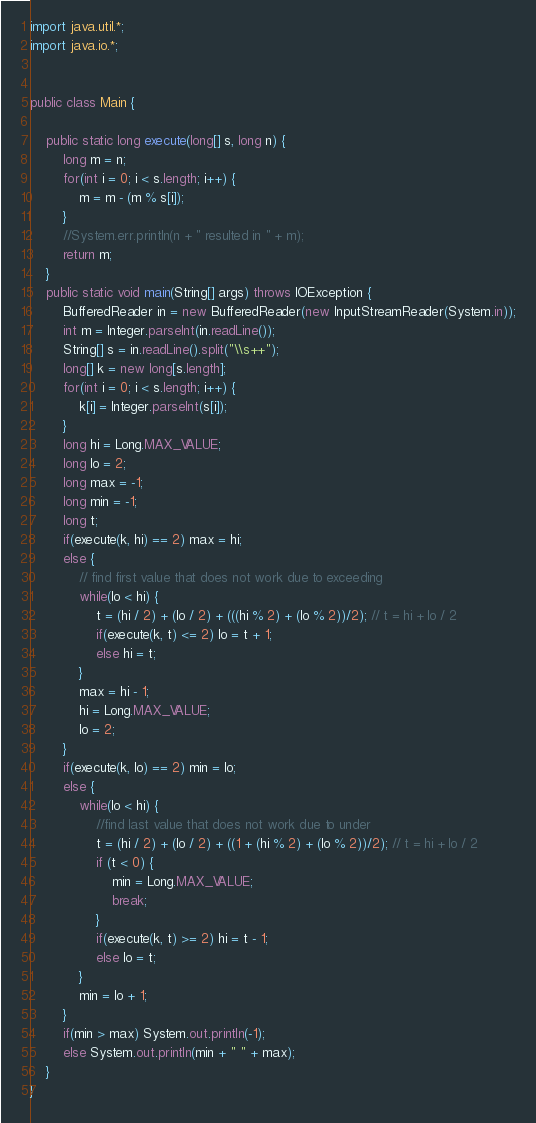Convert code to text. <code><loc_0><loc_0><loc_500><loc_500><_Java_>import java.util.*;
import java.io.*;


public class Main {
	
	public static long execute(long[] s, long n) {
		long m = n;
		for(int i = 0; i < s.length; i++) {
			m = m - (m % s[i]);
		}
		//System.err.println(n + " resulted in " + m);
		return m;
	}
	public static void main(String[] args) throws IOException {
		BufferedReader in = new BufferedReader(new InputStreamReader(System.in));
		int m = Integer.parseInt(in.readLine());
		String[] s = in.readLine().split("\\s++");
		long[] k = new long[s.length];
		for(int i = 0; i < s.length; i++) {
			k[i] = Integer.parseInt(s[i]);
		}
		long hi = Long.MAX_VALUE;
		long lo = 2;
		long max = -1;
		long min = -1;
		long t;
		if(execute(k, hi) == 2) max = hi;
		else {
			// find first value that does not work due to exceeding
			while(lo < hi) {
				t = (hi / 2) + (lo / 2) + (((hi % 2) + (lo % 2))/2); // t = hi + lo / 2
				if(execute(k, t) <= 2) lo = t + 1;
				else hi = t;
			}
			max = hi - 1;
			hi = Long.MAX_VALUE;
			lo = 2;
		}
		if(execute(k, lo) == 2) min = lo;
		else {
			while(lo < hi) {
				//find last value that does not work due to under
				t = (hi / 2) + (lo / 2) + ((1 + (hi % 2) + (lo % 2))/2); // t = hi + lo / 2
				if (t < 0) {
					min = Long.MAX_VALUE;
					break;
				}
				if(execute(k, t) >= 2) hi = t - 1;
				else lo = t;
			}
			min = lo + 1;
		}
		if(min > max) System.out.println(-1);
		else System.out.println(min + " " + max);
	}
}</code> 